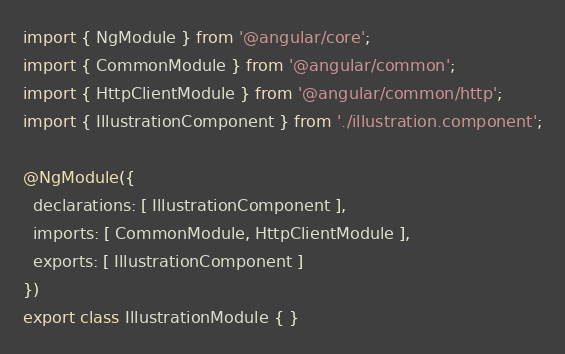Convert code to text. <code><loc_0><loc_0><loc_500><loc_500><_TypeScript_>import { NgModule } from '@angular/core';
import { CommonModule } from '@angular/common';
import { HttpClientModule } from '@angular/common/http';
import { IllustrationComponent } from './illustration.component';

@NgModule({
  declarations: [ IllustrationComponent ],
  imports: [ CommonModule, HttpClientModule ],
  exports: [ IllustrationComponent ]
})
export class IllustrationModule { }
</code> 